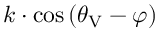Convert formula to latex. <formula><loc_0><loc_0><loc_500><loc_500>k \cdot \cos { ( \theta _ { V } - \varphi ) }</formula> 